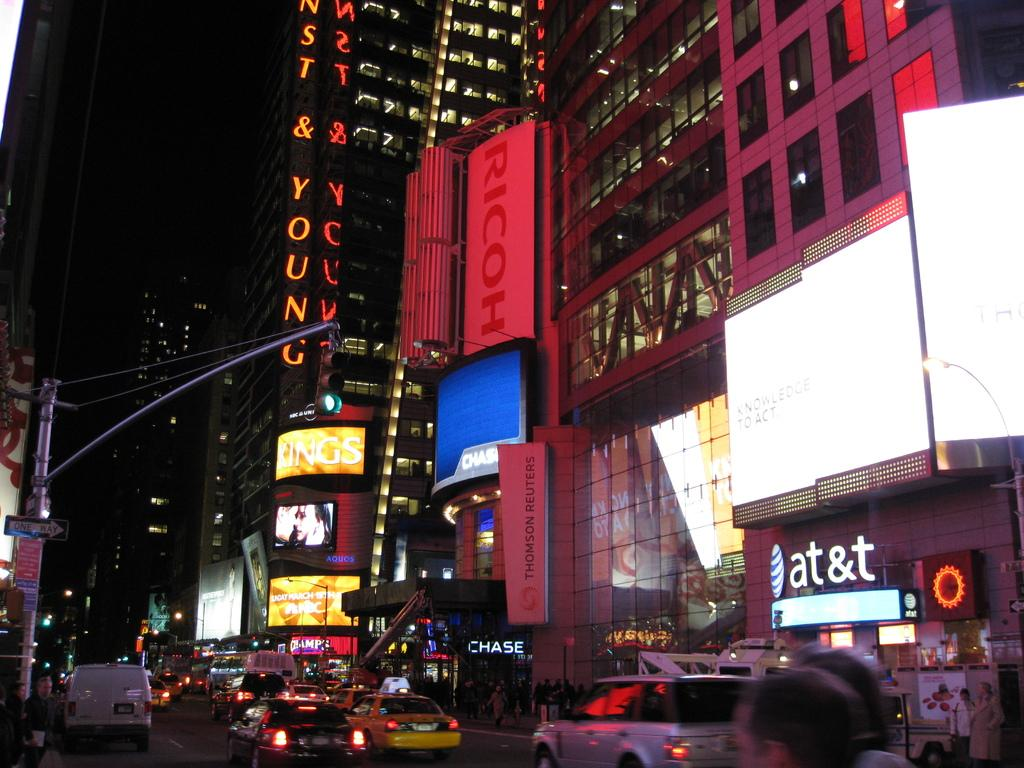Provide a one-sentence caption for the provided image. A sign showing the distance to Alice Springs and Maynard stands in the desert. 